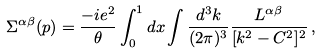Convert formula to latex. <formula><loc_0><loc_0><loc_500><loc_500>\Sigma ^ { \alpha \beta } ( p ) = \frac { - i e ^ { 2 } } { \theta } \int _ { 0 } ^ { 1 } d x \int \frac { d ^ { 3 } k } { ( 2 \pi ) ^ { 3 } } \frac { L ^ { \alpha \beta } } { [ k ^ { 2 } - C ^ { 2 } ] ^ { 2 } } \, ,</formula> 